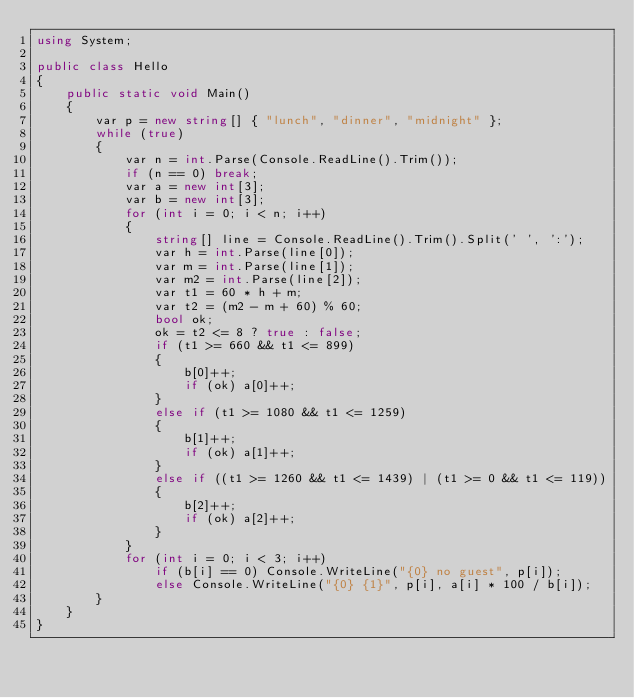Convert code to text. <code><loc_0><loc_0><loc_500><loc_500><_C#_>using System;

public class Hello
{
    public static void Main()
    {
        var p = new string[] { "lunch", "dinner", "midnight" };
        while (true)
        {
            var n = int.Parse(Console.ReadLine().Trim());
            if (n == 0) break;
            var a = new int[3];
            var b = new int[3];
            for (int i = 0; i < n; i++)
            {
                string[] line = Console.ReadLine().Trim().Split(' ', ':');
                var h = int.Parse(line[0]);
                var m = int.Parse(line[1]);
                var m2 = int.Parse(line[2]);
                var t1 = 60 * h + m;
                var t2 = (m2 - m + 60) % 60;
                bool ok;
                ok = t2 <= 8 ? true : false;
                if (t1 >= 660 && t1 <= 899)
                {
                    b[0]++;
                    if (ok) a[0]++;
                }
                else if (t1 >= 1080 && t1 <= 1259)
                {
                    b[1]++;
                    if (ok) a[1]++;
                }
                else if ((t1 >= 1260 && t1 <= 1439) | (t1 >= 0 && t1 <= 119))
                {
                    b[2]++;
                    if (ok) a[2]++;
                }
            }
            for (int i = 0; i < 3; i++)
                if (b[i] == 0) Console.WriteLine("{0} no guest", p[i]);
                else Console.WriteLine("{0} {1}", p[i], a[i] * 100 / b[i]);
        }
    }
}
</code> 